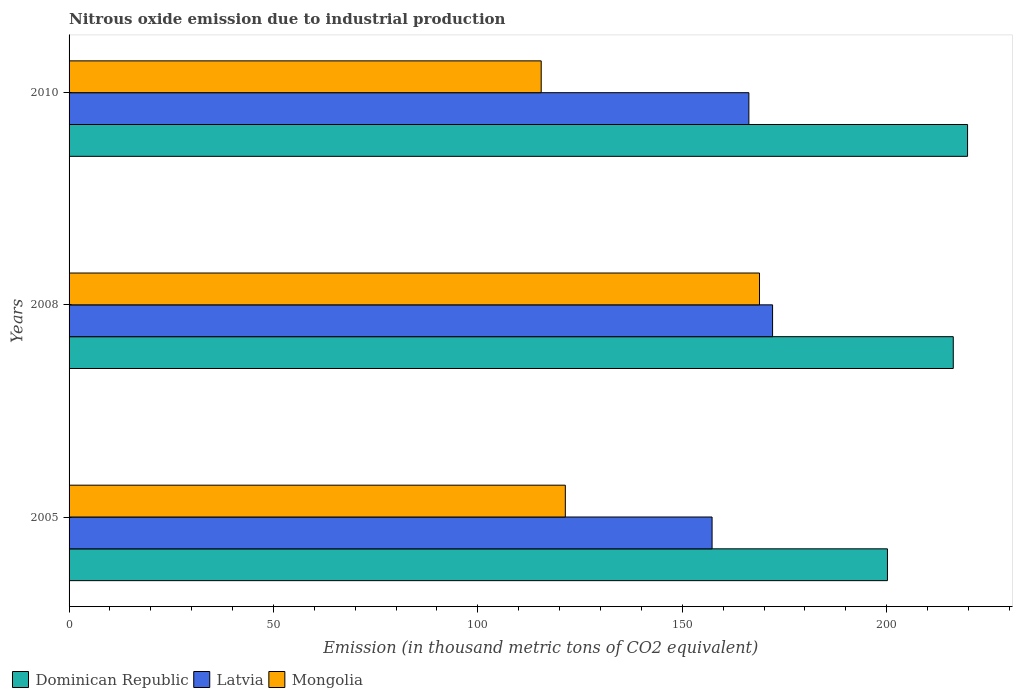Are the number of bars on each tick of the Y-axis equal?
Provide a short and direct response. Yes. How many bars are there on the 3rd tick from the top?
Make the answer very short. 3. How many bars are there on the 3rd tick from the bottom?
Your answer should be compact. 3. What is the label of the 3rd group of bars from the top?
Give a very brief answer. 2005. In how many cases, is the number of bars for a given year not equal to the number of legend labels?
Give a very brief answer. 0. What is the amount of nitrous oxide emitted in Latvia in 2010?
Provide a short and direct response. 166.3. Across all years, what is the maximum amount of nitrous oxide emitted in Latvia?
Your answer should be compact. 172.1. Across all years, what is the minimum amount of nitrous oxide emitted in Latvia?
Give a very brief answer. 157.3. In which year was the amount of nitrous oxide emitted in Mongolia maximum?
Offer a terse response. 2008. In which year was the amount of nitrous oxide emitted in Dominican Republic minimum?
Your answer should be compact. 2005. What is the total amount of nitrous oxide emitted in Dominican Republic in the graph?
Your response must be concise. 636.3. What is the difference between the amount of nitrous oxide emitted in Mongolia in 2008 and that in 2010?
Provide a succinct answer. 53.4. What is the difference between the amount of nitrous oxide emitted in Dominican Republic in 2010 and the amount of nitrous oxide emitted in Mongolia in 2005?
Provide a short and direct response. 98.4. What is the average amount of nitrous oxide emitted in Dominican Republic per year?
Your response must be concise. 212.1. In the year 2010, what is the difference between the amount of nitrous oxide emitted in Latvia and amount of nitrous oxide emitted in Dominican Republic?
Provide a short and direct response. -53.5. In how many years, is the amount of nitrous oxide emitted in Latvia greater than 220 thousand metric tons?
Provide a short and direct response. 0. What is the ratio of the amount of nitrous oxide emitted in Mongolia in 2008 to that in 2010?
Your response must be concise. 1.46. Is the amount of nitrous oxide emitted in Latvia in 2005 less than that in 2010?
Make the answer very short. Yes. Is the difference between the amount of nitrous oxide emitted in Latvia in 2005 and 2010 greater than the difference between the amount of nitrous oxide emitted in Dominican Republic in 2005 and 2010?
Ensure brevity in your answer.  Yes. What is the difference between the highest and the second highest amount of nitrous oxide emitted in Latvia?
Offer a very short reply. 5.8. What is the difference between the highest and the lowest amount of nitrous oxide emitted in Mongolia?
Offer a terse response. 53.4. In how many years, is the amount of nitrous oxide emitted in Dominican Republic greater than the average amount of nitrous oxide emitted in Dominican Republic taken over all years?
Offer a very short reply. 2. What does the 1st bar from the top in 2008 represents?
Your answer should be very brief. Mongolia. What does the 1st bar from the bottom in 2010 represents?
Your answer should be very brief. Dominican Republic. Is it the case that in every year, the sum of the amount of nitrous oxide emitted in Mongolia and amount of nitrous oxide emitted in Dominican Republic is greater than the amount of nitrous oxide emitted in Latvia?
Provide a succinct answer. Yes. How many years are there in the graph?
Your response must be concise. 3. What is the difference between two consecutive major ticks on the X-axis?
Offer a terse response. 50. Does the graph contain any zero values?
Provide a succinct answer. No. What is the title of the graph?
Your answer should be very brief. Nitrous oxide emission due to industrial production. What is the label or title of the X-axis?
Offer a very short reply. Emission (in thousand metric tons of CO2 equivalent). What is the Emission (in thousand metric tons of CO2 equivalent) in Dominican Republic in 2005?
Ensure brevity in your answer.  200.2. What is the Emission (in thousand metric tons of CO2 equivalent) of Latvia in 2005?
Offer a terse response. 157.3. What is the Emission (in thousand metric tons of CO2 equivalent) of Mongolia in 2005?
Your response must be concise. 121.4. What is the Emission (in thousand metric tons of CO2 equivalent) in Dominican Republic in 2008?
Keep it short and to the point. 216.3. What is the Emission (in thousand metric tons of CO2 equivalent) of Latvia in 2008?
Ensure brevity in your answer.  172.1. What is the Emission (in thousand metric tons of CO2 equivalent) in Mongolia in 2008?
Provide a short and direct response. 168.9. What is the Emission (in thousand metric tons of CO2 equivalent) of Dominican Republic in 2010?
Keep it short and to the point. 219.8. What is the Emission (in thousand metric tons of CO2 equivalent) in Latvia in 2010?
Make the answer very short. 166.3. What is the Emission (in thousand metric tons of CO2 equivalent) of Mongolia in 2010?
Your answer should be very brief. 115.5. Across all years, what is the maximum Emission (in thousand metric tons of CO2 equivalent) of Dominican Republic?
Make the answer very short. 219.8. Across all years, what is the maximum Emission (in thousand metric tons of CO2 equivalent) of Latvia?
Ensure brevity in your answer.  172.1. Across all years, what is the maximum Emission (in thousand metric tons of CO2 equivalent) in Mongolia?
Your answer should be compact. 168.9. Across all years, what is the minimum Emission (in thousand metric tons of CO2 equivalent) of Dominican Republic?
Ensure brevity in your answer.  200.2. Across all years, what is the minimum Emission (in thousand metric tons of CO2 equivalent) in Latvia?
Offer a terse response. 157.3. Across all years, what is the minimum Emission (in thousand metric tons of CO2 equivalent) of Mongolia?
Your response must be concise. 115.5. What is the total Emission (in thousand metric tons of CO2 equivalent) in Dominican Republic in the graph?
Provide a short and direct response. 636.3. What is the total Emission (in thousand metric tons of CO2 equivalent) of Latvia in the graph?
Provide a short and direct response. 495.7. What is the total Emission (in thousand metric tons of CO2 equivalent) in Mongolia in the graph?
Make the answer very short. 405.8. What is the difference between the Emission (in thousand metric tons of CO2 equivalent) of Dominican Republic in 2005 and that in 2008?
Keep it short and to the point. -16.1. What is the difference between the Emission (in thousand metric tons of CO2 equivalent) of Latvia in 2005 and that in 2008?
Give a very brief answer. -14.8. What is the difference between the Emission (in thousand metric tons of CO2 equivalent) of Mongolia in 2005 and that in 2008?
Make the answer very short. -47.5. What is the difference between the Emission (in thousand metric tons of CO2 equivalent) in Dominican Republic in 2005 and that in 2010?
Your answer should be very brief. -19.6. What is the difference between the Emission (in thousand metric tons of CO2 equivalent) in Latvia in 2005 and that in 2010?
Give a very brief answer. -9. What is the difference between the Emission (in thousand metric tons of CO2 equivalent) in Mongolia in 2005 and that in 2010?
Offer a terse response. 5.9. What is the difference between the Emission (in thousand metric tons of CO2 equivalent) of Mongolia in 2008 and that in 2010?
Provide a succinct answer. 53.4. What is the difference between the Emission (in thousand metric tons of CO2 equivalent) in Dominican Republic in 2005 and the Emission (in thousand metric tons of CO2 equivalent) in Latvia in 2008?
Provide a succinct answer. 28.1. What is the difference between the Emission (in thousand metric tons of CO2 equivalent) of Dominican Republic in 2005 and the Emission (in thousand metric tons of CO2 equivalent) of Mongolia in 2008?
Give a very brief answer. 31.3. What is the difference between the Emission (in thousand metric tons of CO2 equivalent) in Dominican Republic in 2005 and the Emission (in thousand metric tons of CO2 equivalent) in Latvia in 2010?
Keep it short and to the point. 33.9. What is the difference between the Emission (in thousand metric tons of CO2 equivalent) of Dominican Republic in 2005 and the Emission (in thousand metric tons of CO2 equivalent) of Mongolia in 2010?
Your response must be concise. 84.7. What is the difference between the Emission (in thousand metric tons of CO2 equivalent) in Latvia in 2005 and the Emission (in thousand metric tons of CO2 equivalent) in Mongolia in 2010?
Give a very brief answer. 41.8. What is the difference between the Emission (in thousand metric tons of CO2 equivalent) in Dominican Republic in 2008 and the Emission (in thousand metric tons of CO2 equivalent) in Latvia in 2010?
Ensure brevity in your answer.  50. What is the difference between the Emission (in thousand metric tons of CO2 equivalent) in Dominican Republic in 2008 and the Emission (in thousand metric tons of CO2 equivalent) in Mongolia in 2010?
Make the answer very short. 100.8. What is the difference between the Emission (in thousand metric tons of CO2 equivalent) in Latvia in 2008 and the Emission (in thousand metric tons of CO2 equivalent) in Mongolia in 2010?
Ensure brevity in your answer.  56.6. What is the average Emission (in thousand metric tons of CO2 equivalent) in Dominican Republic per year?
Your answer should be compact. 212.1. What is the average Emission (in thousand metric tons of CO2 equivalent) of Latvia per year?
Your response must be concise. 165.23. What is the average Emission (in thousand metric tons of CO2 equivalent) in Mongolia per year?
Ensure brevity in your answer.  135.27. In the year 2005, what is the difference between the Emission (in thousand metric tons of CO2 equivalent) in Dominican Republic and Emission (in thousand metric tons of CO2 equivalent) in Latvia?
Keep it short and to the point. 42.9. In the year 2005, what is the difference between the Emission (in thousand metric tons of CO2 equivalent) in Dominican Republic and Emission (in thousand metric tons of CO2 equivalent) in Mongolia?
Ensure brevity in your answer.  78.8. In the year 2005, what is the difference between the Emission (in thousand metric tons of CO2 equivalent) of Latvia and Emission (in thousand metric tons of CO2 equivalent) of Mongolia?
Your answer should be very brief. 35.9. In the year 2008, what is the difference between the Emission (in thousand metric tons of CO2 equivalent) in Dominican Republic and Emission (in thousand metric tons of CO2 equivalent) in Latvia?
Provide a short and direct response. 44.2. In the year 2008, what is the difference between the Emission (in thousand metric tons of CO2 equivalent) in Dominican Republic and Emission (in thousand metric tons of CO2 equivalent) in Mongolia?
Your answer should be very brief. 47.4. In the year 2010, what is the difference between the Emission (in thousand metric tons of CO2 equivalent) of Dominican Republic and Emission (in thousand metric tons of CO2 equivalent) of Latvia?
Give a very brief answer. 53.5. In the year 2010, what is the difference between the Emission (in thousand metric tons of CO2 equivalent) of Dominican Republic and Emission (in thousand metric tons of CO2 equivalent) of Mongolia?
Offer a very short reply. 104.3. In the year 2010, what is the difference between the Emission (in thousand metric tons of CO2 equivalent) of Latvia and Emission (in thousand metric tons of CO2 equivalent) of Mongolia?
Ensure brevity in your answer.  50.8. What is the ratio of the Emission (in thousand metric tons of CO2 equivalent) of Dominican Republic in 2005 to that in 2008?
Give a very brief answer. 0.93. What is the ratio of the Emission (in thousand metric tons of CO2 equivalent) of Latvia in 2005 to that in 2008?
Your answer should be very brief. 0.91. What is the ratio of the Emission (in thousand metric tons of CO2 equivalent) of Mongolia in 2005 to that in 2008?
Provide a succinct answer. 0.72. What is the ratio of the Emission (in thousand metric tons of CO2 equivalent) of Dominican Republic in 2005 to that in 2010?
Keep it short and to the point. 0.91. What is the ratio of the Emission (in thousand metric tons of CO2 equivalent) in Latvia in 2005 to that in 2010?
Your answer should be compact. 0.95. What is the ratio of the Emission (in thousand metric tons of CO2 equivalent) in Mongolia in 2005 to that in 2010?
Provide a succinct answer. 1.05. What is the ratio of the Emission (in thousand metric tons of CO2 equivalent) of Dominican Republic in 2008 to that in 2010?
Provide a succinct answer. 0.98. What is the ratio of the Emission (in thousand metric tons of CO2 equivalent) of Latvia in 2008 to that in 2010?
Keep it short and to the point. 1.03. What is the ratio of the Emission (in thousand metric tons of CO2 equivalent) of Mongolia in 2008 to that in 2010?
Give a very brief answer. 1.46. What is the difference between the highest and the second highest Emission (in thousand metric tons of CO2 equivalent) in Dominican Republic?
Your answer should be compact. 3.5. What is the difference between the highest and the second highest Emission (in thousand metric tons of CO2 equivalent) in Mongolia?
Provide a short and direct response. 47.5. What is the difference between the highest and the lowest Emission (in thousand metric tons of CO2 equivalent) in Dominican Republic?
Make the answer very short. 19.6. What is the difference between the highest and the lowest Emission (in thousand metric tons of CO2 equivalent) of Mongolia?
Make the answer very short. 53.4. 